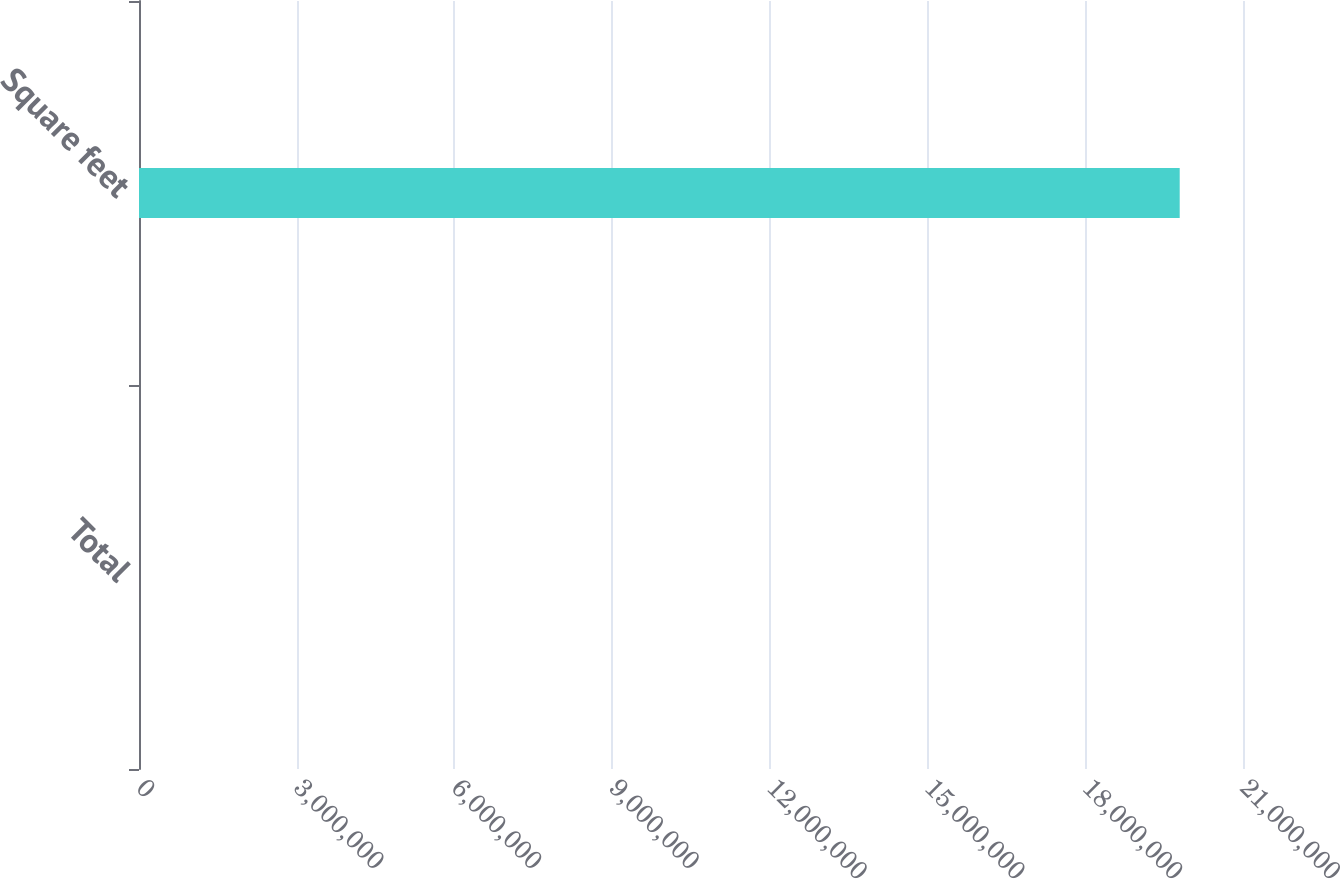Convert chart to OTSL. <chart><loc_0><loc_0><loc_500><loc_500><bar_chart><fcel>Total<fcel>Square feet<nl><fcel>255<fcel>1.9796e+07<nl></chart> 